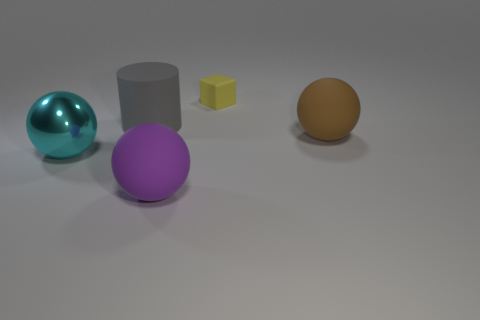What are the different materials and textures present in the objects shown in the image? In the image, we see objects with various materials and textures. The sphere to the left has a shiny, reflective metallic surface with a cyan tint, suggesting it could be metallic. The large purple sphere in the center has a matte texture, providing a non-glossy appearance. There is also a gray cylinder that appears to have a similar matte finish. The small cube and the large sphere on the right seem to share a smooth, but non-reflective, matte texture as well, with the cube being more brightly colored in comparison. 